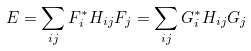<formula> <loc_0><loc_0><loc_500><loc_500>E = \sum _ { i j } F _ { i } ^ { * } H _ { i j } F _ { j } = \sum _ { i j } G _ { i } ^ { * } H _ { i j } G _ { j }</formula> 